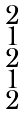<formula> <loc_0><loc_0><loc_500><loc_500>\begin{smallmatrix} 2 \\ 1 \\ 2 \\ 1 \\ 2 \end{smallmatrix}</formula> 